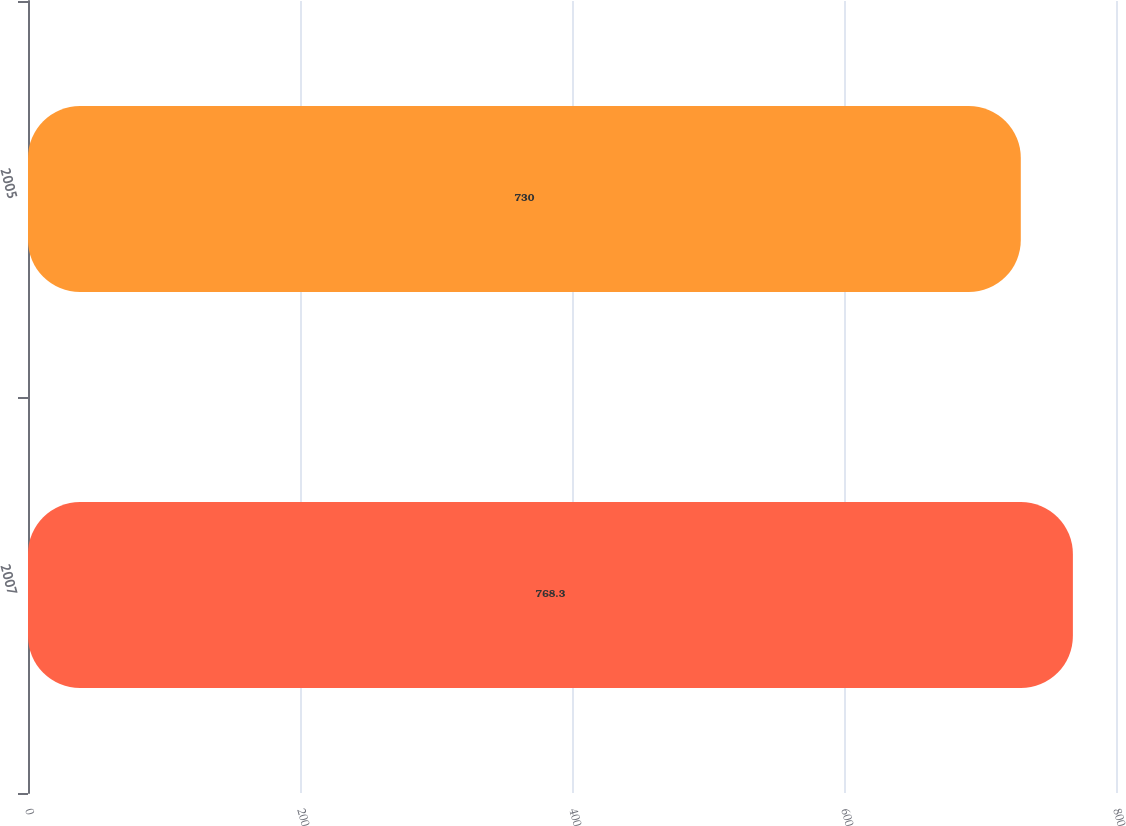<chart> <loc_0><loc_0><loc_500><loc_500><bar_chart><fcel>2007<fcel>2005<nl><fcel>768.3<fcel>730<nl></chart> 